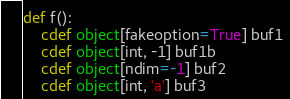Convert code to text. <code><loc_0><loc_0><loc_500><loc_500><_Cython_>
def f():
    cdef object[fakeoption=True] buf1
    cdef object[int, -1] buf1b
    cdef object[ndim=-1] buf2
    cdef object[int, 'a'] buf3</code> 